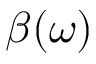<formula> <loc_0><loc_0><loc_500><loc_500>\beta ( \omega )</formula> 